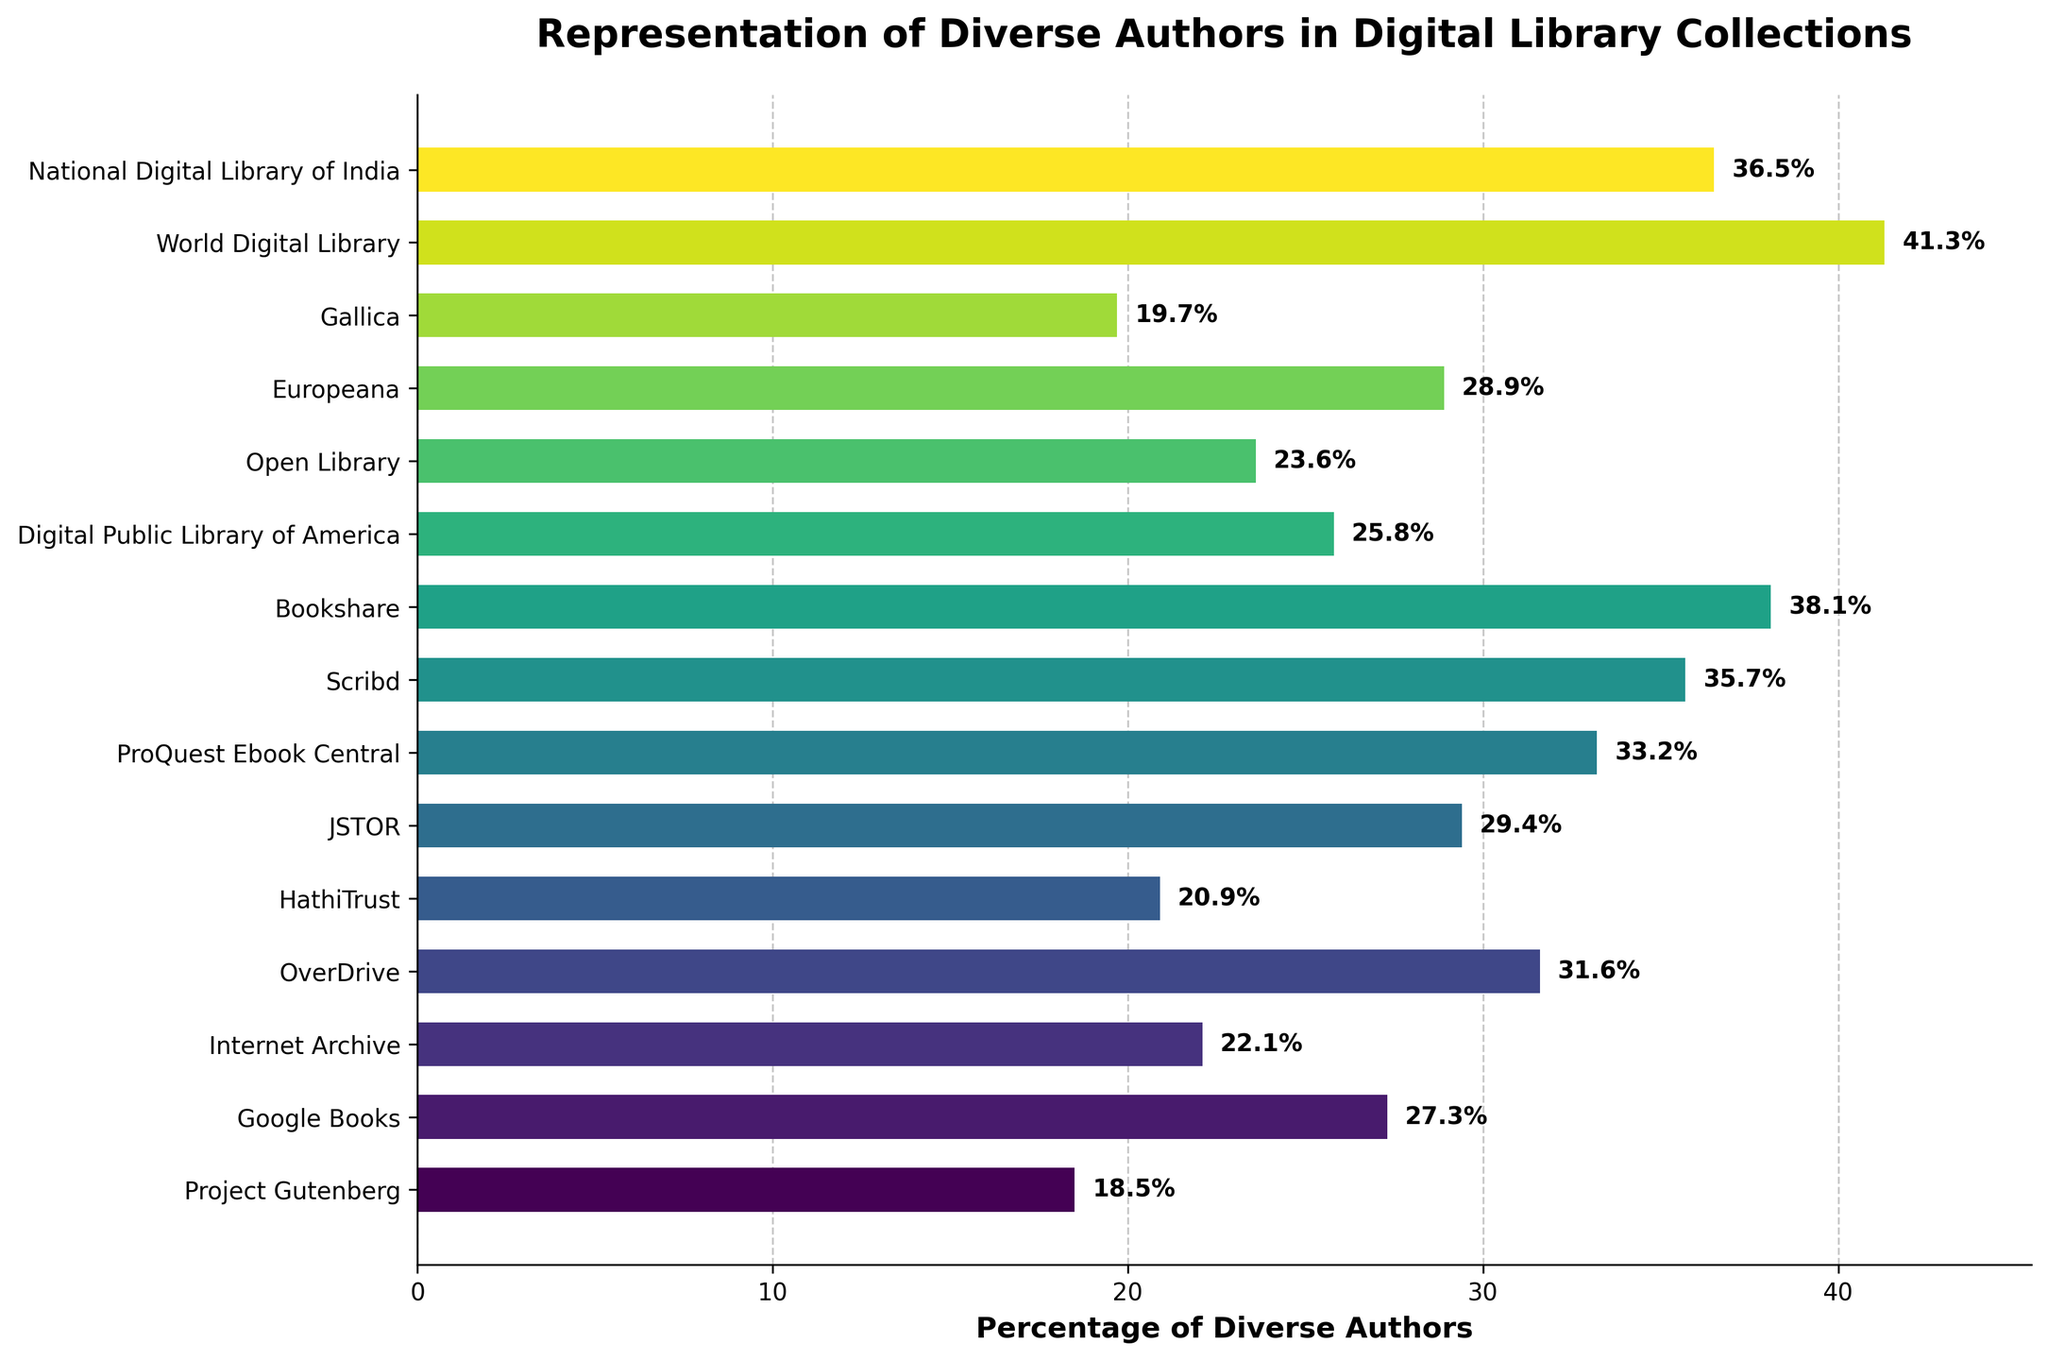Which platform has the highest percentage of diverse authors? By examining the lengths of the bars in the chart, we can find the platform with the longest bar, which corresponds to the highest percentage. The World Digital Library has the longest bar.
Answer: World Digital Library How much higher is the percentage of diverse authors in ProQuest Ebook Central compared to HathiTrust? First, find the percentages for ProQuest Ebook Central (33.2%) and HathiTrust (20.9%). Then, perform the subtraction: 33.2% - 20.9% = 12.3%.
Answer: 12.3% Rank the top three platforms in terms of representation of diverse authors. By visually comparing the bar lengths, we identify the top three as follows: World Digital Library (41.3%), Bookshare (38.1%), National Digital Library of India (36.5%).
Answer: World Digital Library, Bookshare, National Digital Library of India What is the average percentage of diverse authors across all the platforms in the chart? Sum all percentages: 18.5 + 27.3 + 22.1 + 31.6 + 20.9 + 29.4 + 33.2 + 35.7 + 38.1 + 25.8 + 23.6 + 28.9 + 19.7 + 41.3 + 36.5 = 432.6; then divide by the number of platforms: 432.6 / 15 = 28.84%.
Answer: 28.84% Which platform has the closest percentage of diverse authors to the overall average? First, calculate the average as 28.84%. Then, find the platform with the percentage closest to this average. By comparing 28.84% to each value, we determine that Europeana (28.9%) is the closest.
Answer: Europeana Is the representation of diverse authors in Scribd greater than in JSTOR? By comparing the percentages of Scribd (35.7%) and JSTOR (29.4%), we see that 35.7% is greater than 29.4%.
Answer: Yes What is the difference in percentage points between Google Books and Project Gutenberg? Subtract the percentage for Project Gutenberg (18.5%) from Google Books (27.3%): 27.3% - 18.5% = 8.8%.
Answer: 8.8% Identify the platform with the lowest percentage representation of diverse authors and provide its value. By finding the shortest bar in the chart, we identify Project Gutenberg with the lowest value of 18.5%.
Answer: Project Gutenberg, 18.5% Calculate the total percentage of diverse authors for the platforms represented by JSTOR, Scribd, and Bookshare combined. Sum the percentages: 29.4% (JSTOR) + 35.7% (Scribd) + 38.1% (Bookshare) = 103.2%.
Answer: 103.2% Which two platforms have the closest percentages of diverse authors? Compare all neighboring percentage values, and the closest are Google Books (27.3%) and JSTOR (29.4%) with a difference of 2.1%.
Answer: Google Books and JSTOR 